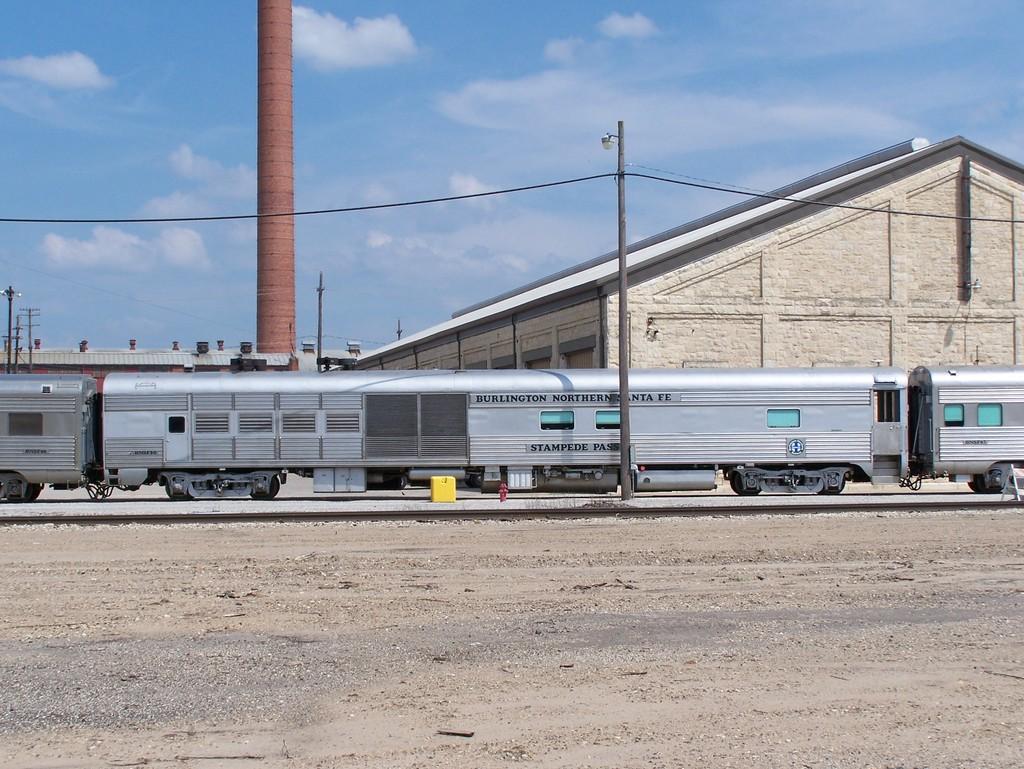What is the name on the train?
Make the answer very short. Burlington northern santa fe. What is the first city written on the train?
Your answer should be compact. Burlington. 